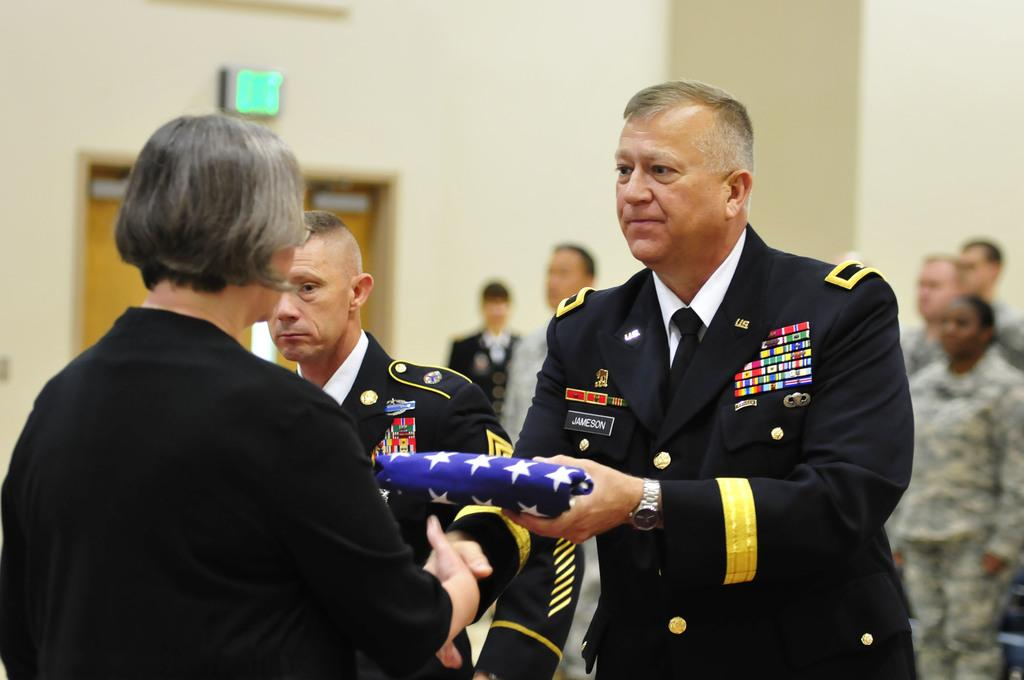What is the main setting of the picture? There is a room in the picture. How many people are present in the room? There are many people standing in the room. What is the man holding in his hand? There is a man holding an object with his hand. What can be observed about the people behind the man? There are people wearing the same costume behind the man. What type of harmony is being played by the people in the room? There is no indication of music or harmony in the image; it only shows people standing in a room. 